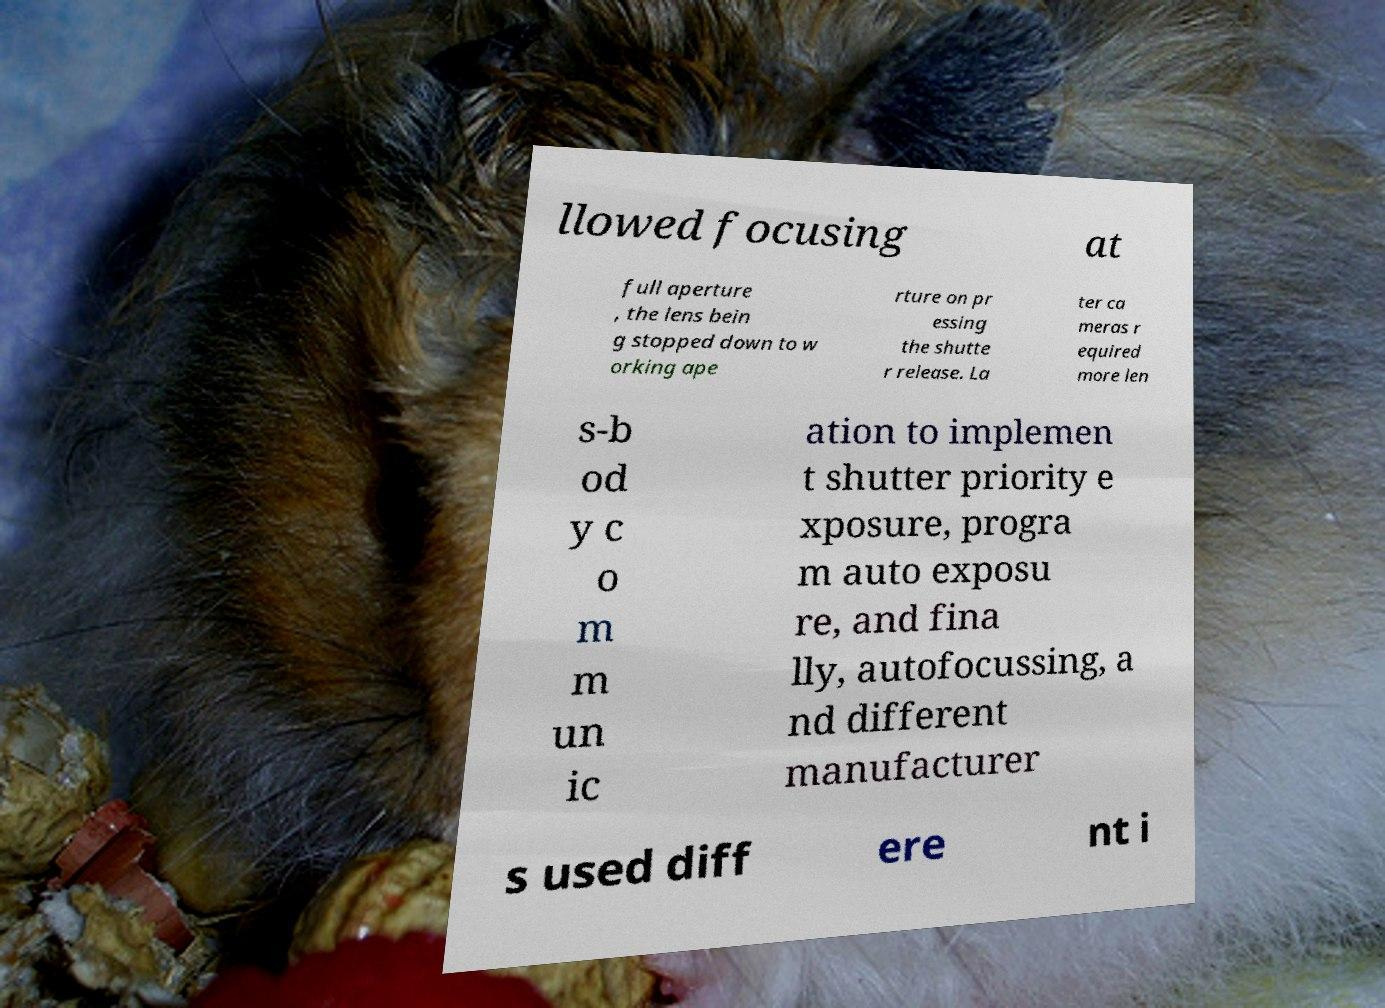Please read and relay the text visible in this image. What does it say? llowed focusing at full aperture , the lens bein g stopped down to w orking ape rture on pr essing the shutte r release. La ter ca meras r equired more len s-b od y c o m m un ic ation to implemen t shutter priority e xposure, progra m auto exposu re, and fina lly, autofocussing, a nd different manufacturer s used diff ere nt i 